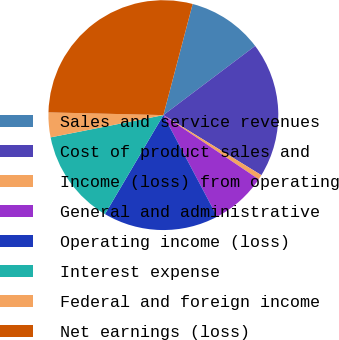Convert chart. <chart><loc_0><loc_0><loc_500><loc_500><pie_chart><fcel>Sales and service revenues<fcel>Cost of product sales and<fcel>Income (loss) from operating<fcel>General and administrative<fcel>Operating income (loss)<fcel>Interest expense<fcel>Federal and foreign income<fcel>Net earnings (loss)<nl><fcel>10.62%<fcel>19.03%<fcel>0.68%<fcel>7.82%<fcel>16.23%<fcel>13.42%<fcel>3.48%<fcel>28.72%<nl></chart> 